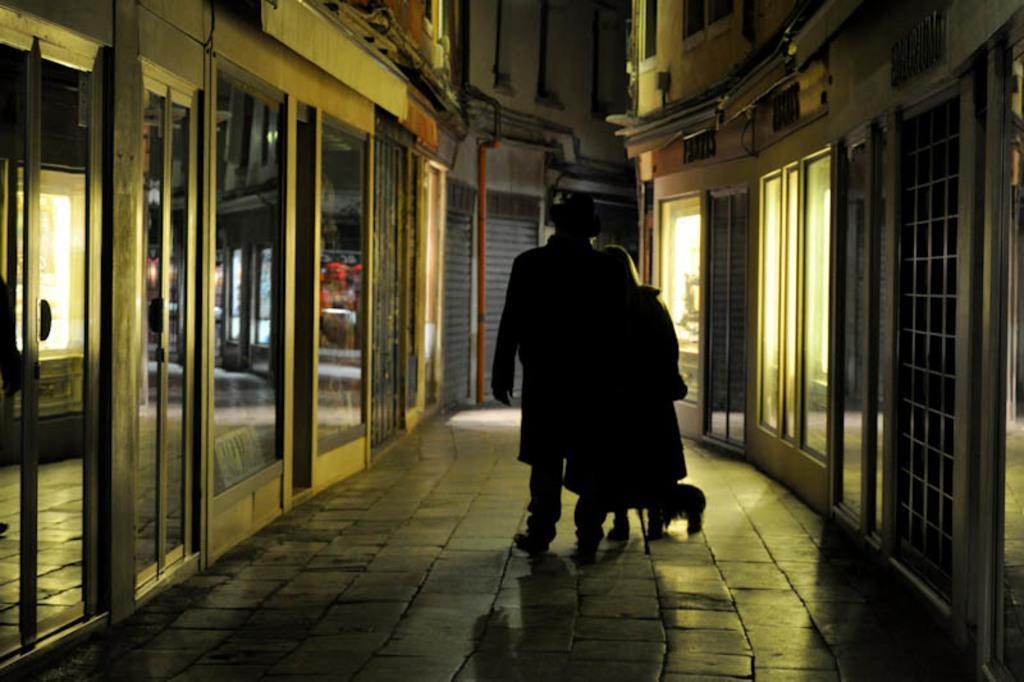Could you give a brief overview of what you see in this image? This is an image clicked in the dark. In the middle of the image there are two persons standing on the floor. On the right and left side of the image I can see the buildings. 